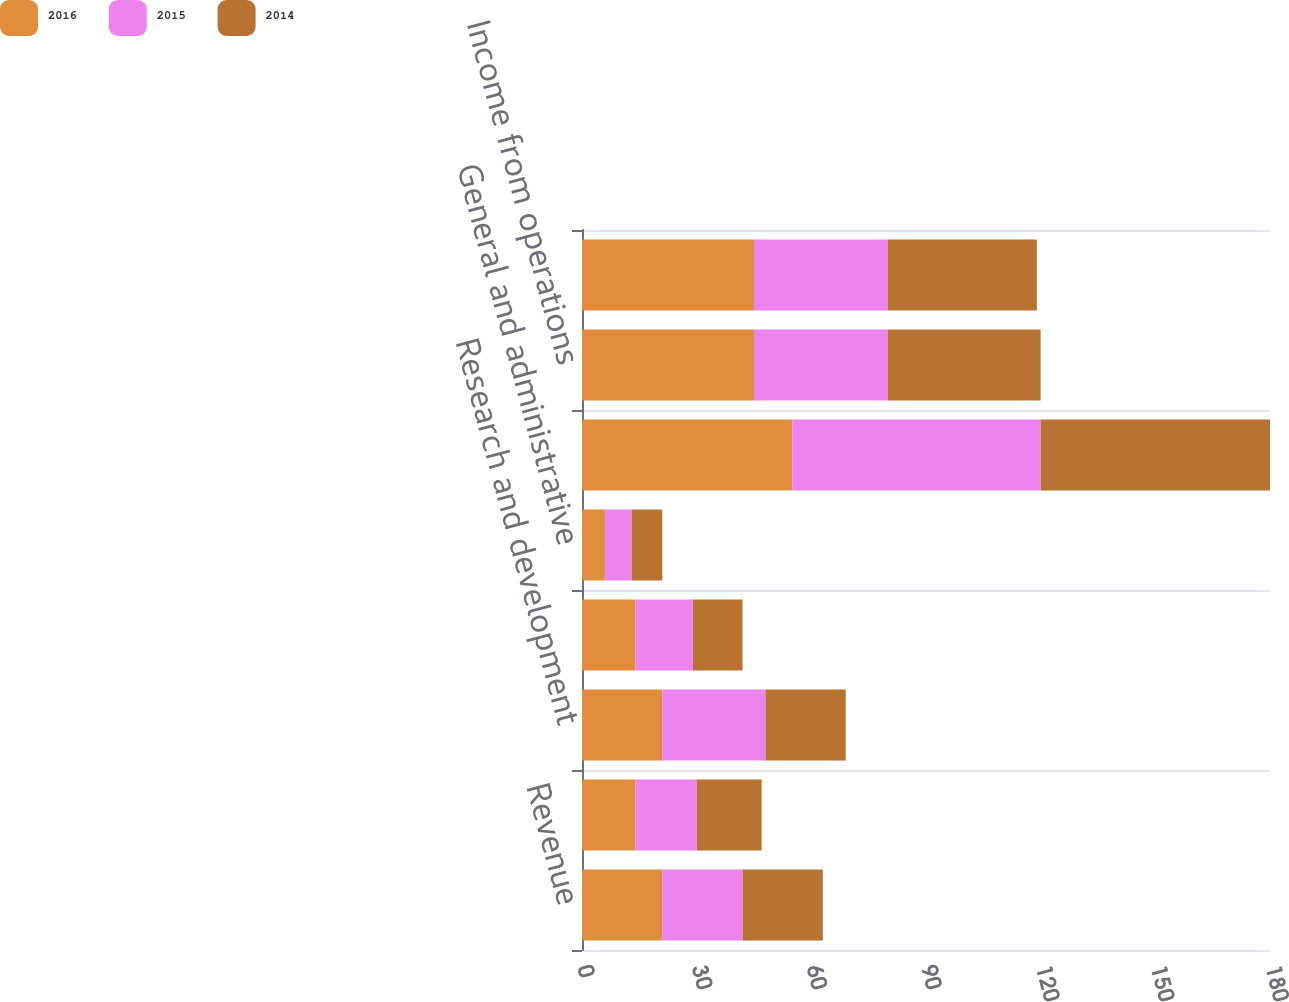<chart> <loc_0><loc_0><loc_500><loc_500><stacked_bar_chart><ecel><fcel>Revenue<fcel>Cost of revenue<fcel>Research and development<fcel>Marketing and sales<fcel>General and administrative<fcel>Total costs and expenses<fcel>Income from operations<fcel>Income before provision for<nl><fcel>2016<fcel>21<fcel>14<fcel>21<fcel>14<fcel>6<fcel>55<fcel>45<fcel>45<nl><fcel>2015<fcel>21<fcel>16<fcel>27<fcel>15<fcel>7<fcel>65<fcel>35<fcel>35<nl><fcel>2014<fcel>21<fcel>17<fcel>21<fcel>13<fcel>8<fcel>60<fcel>40<fcel>39<nl></chart> 